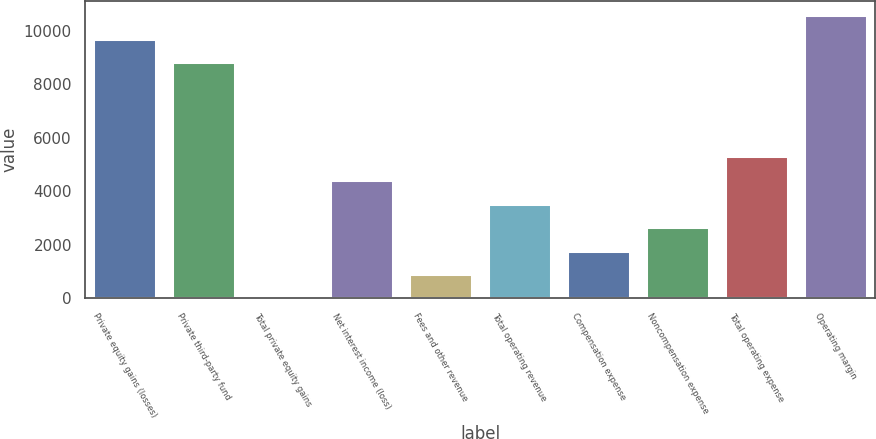Convert chart. <chart><loc_0><loc_0><loc_500><loc_500><bar_chart><fcel>Private equity gains (losses)<fcel>Private third-party fund<fcel>Total private equity gains<fcel>Net interest income (loss)<fcel>Fees and other revenue<fcel>Total operating revenue<fcel>Compensation expense<fcel>Noncompensation expense<fcel>Total operating expense<fcel>Operating margin<nl><fcel>9697.1<fcel>8818<fcel>27<fcel>4422.5<fcel>906.1<fcel>3543.4<fcel>1785.2<fcel>2664.3<fcel>5301.6<fcel>10576.2<nl></chart> 